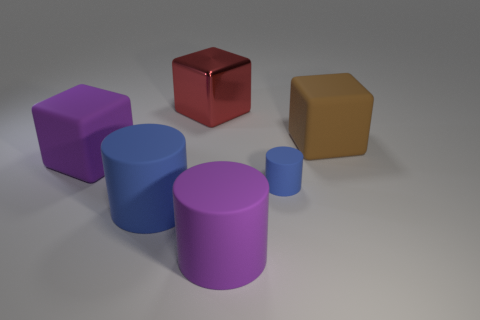Subtract all blue cylinders. How many were subtracted if there are1blue cylinders left? 1 Add 3 big matte cylinders. How many objects exist? 9 Add 6 large purple rubber cylinders. How many large purple rubber cylinders are left? 7 Add 2 tiny yellow metallic cubes. How many tiny yellow metallic cubes exist? 2 Subtract 0 green cylinders. How many objects are left? 6 Subtract all blocks. Subtract all big blue rubber cylinders. How many objects are left? 2 